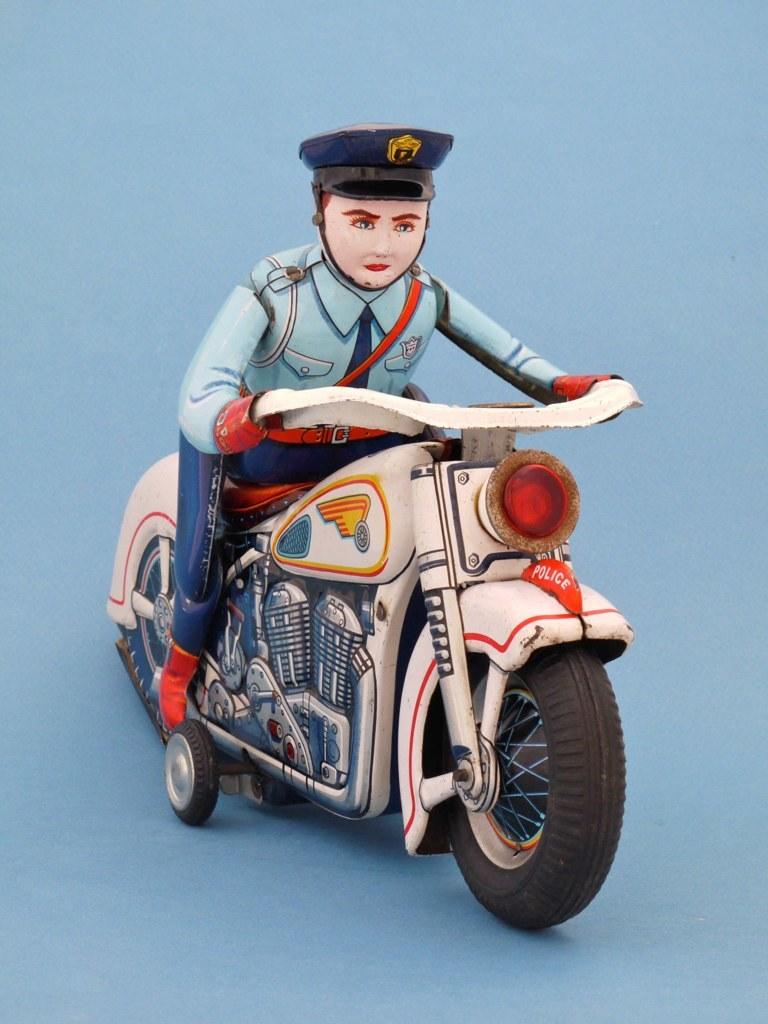Who is in the image? There is a man in the image. What is the man doing in the image? The man is sitting on a motorcycle. What type of magic is the man performing on the motorcycle in the image? There is no magic or any indication of magic in the image; the man is simply sitting on a motorcycle. 